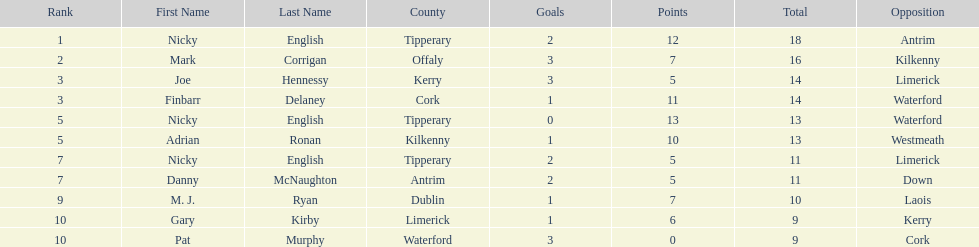What player got 10 total points in their game? M. J. Ryan. 